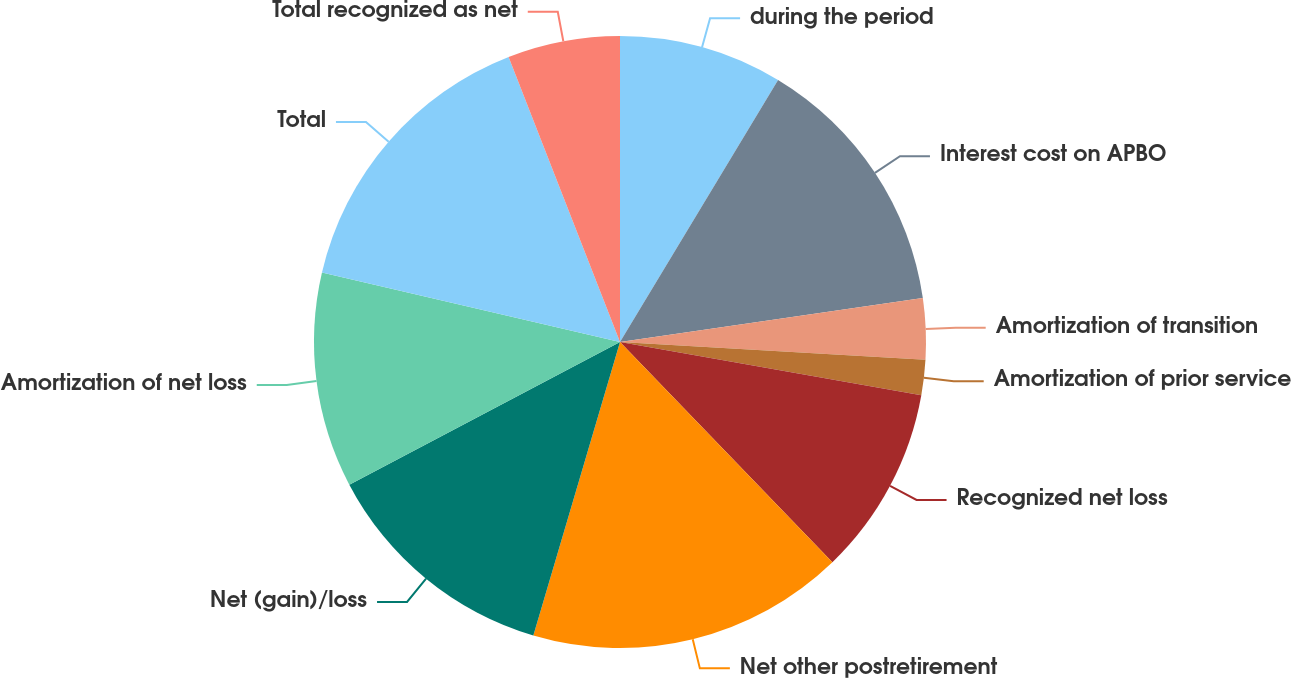Convert chart to OTSL. <chart><loc_0><loc_0><loc_500><loc_500><pie_chart><fcel>during the period<fcel>Interest cost on APBO<fcel>Amortization of transition<fcel>Amortization of prior service<fcel>Recognized net loss<fcel>Net other postretirement<fcel>Net (gain)/loss<fcel>Amortization of net loss<fcel>Total<fcel>Total recognized as net<nl><fcel>8.64%<fcel>14.07%<fcel>3.22%<fcel>1.86%<fcel>10.0%<fcel>16.78%<fcel>12.71%<fcel>11.36%<fcel>15.43%<fcel>5.93%<nl></chart> 